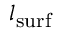<formula> <loc_0><loc_0><loc_500><loc_500>l _ { s u r f }</formula> 